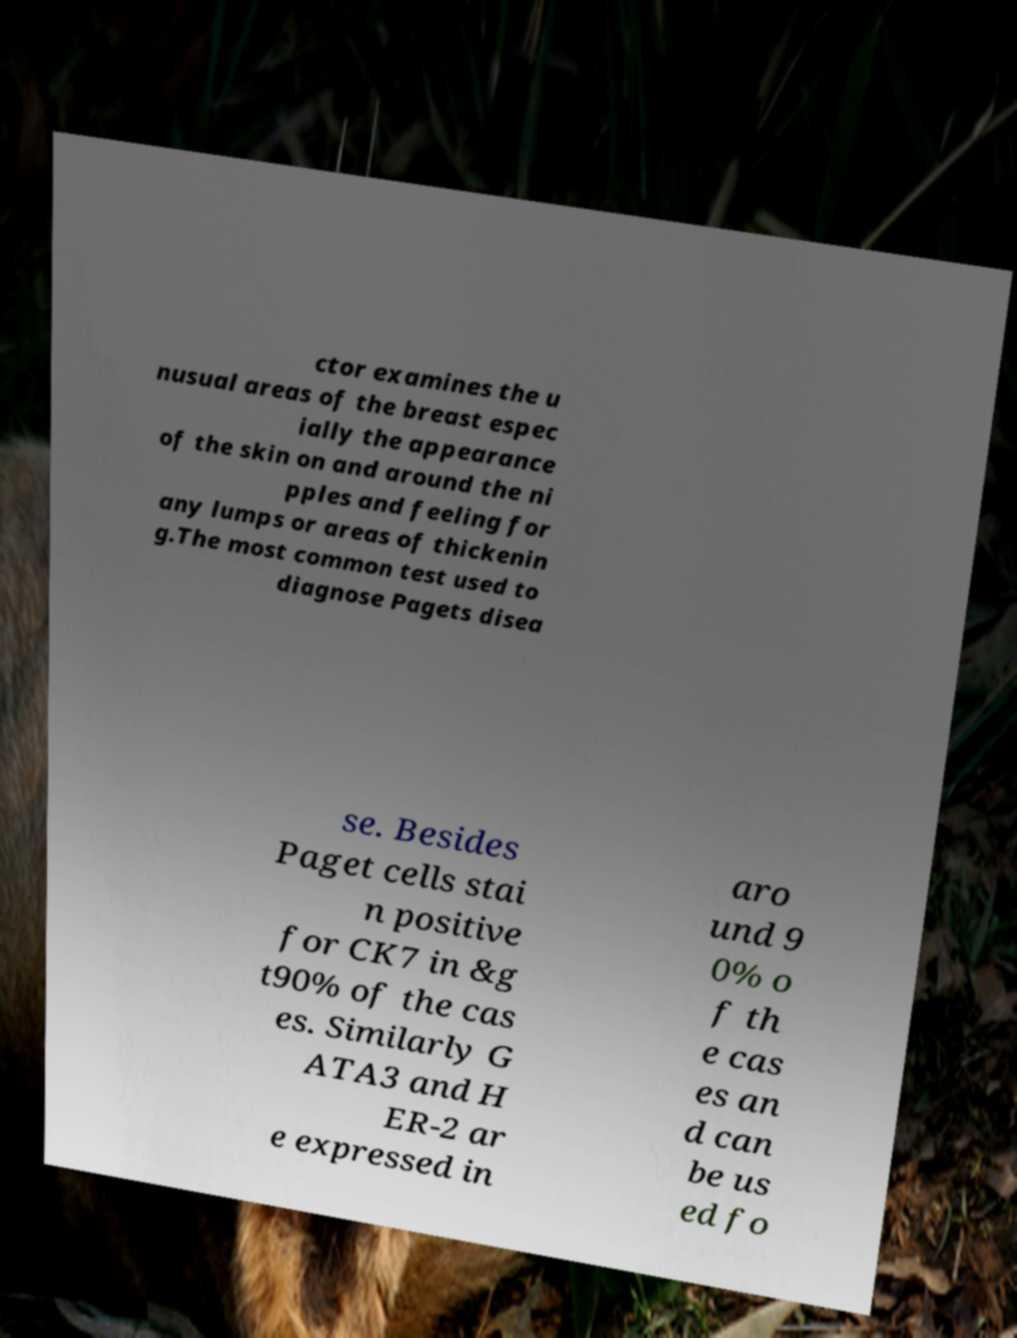Please read and relay the text visible in this image. What does it say? ctor examines the u nusual areas of the breast espec ially the appearance of the skin on and around the ni pples and feeling for any lumps or areas of thickenin g.The most common test used to diagnose Pagets disea se. Besides Paget cells stai n positive for CK7 in &g t90% of the cas es. Similarly G ATA3 and H ER-2 ar e expressed in aro und 9 0% o f th e cas es an d can be us ed fo 